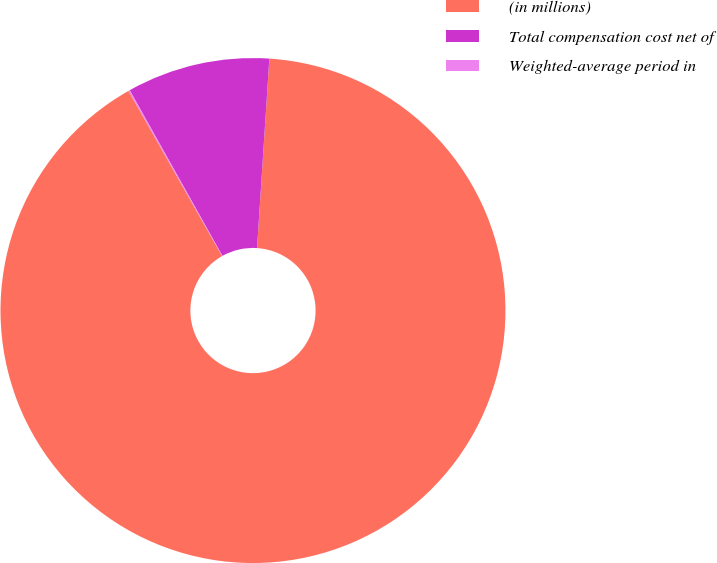<chart> <loc_0><loc_0><loc_500><loc_500><pie_chart><fcel>(in millions)<fcel>Total compensation cost net of<fcel>Weighted-average period in<nl><fcel>90.76%<fcel>9.15%<fcel>0.09%<nl></chart> 